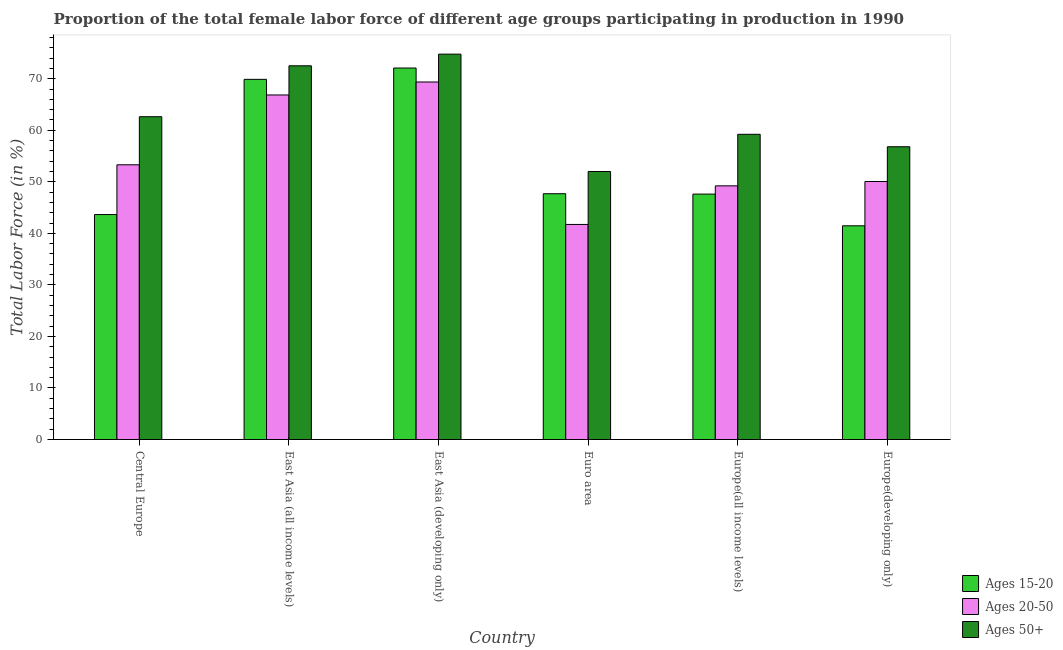How many different coloured bars are there?
Ensure brevity in your answer.  3. How many groups of bars are there?
Ensure brevity in your answer.  6. How many bars are there on the 2nd tick from the right?
Make the answer very short. 3. What is the label of the 5th group of bars from the left?
Provide a succinct answer. Europe(all income levels). In how many cases, is the number of bars for a given country not equal to the number of legend labels?
Your answer should be very brief. 0. What is the percentage of female labor force within the age group 15-20 in Euro area?
Provide a succinct answer. 47.69. Across all countries, what is the maximum percentage of female labor force within the age group 20-50?
Make the answer very short. 69.37. Across all countries, what is the minimum percentage of female labor force above age 50?
Offer a terse response. 52.01. In which country was the percentage of female labor force within the age group 20-50 maximum?
Keep it short and to the point. East Asia (developing only). What is the total percentage of female labor force within the age group 15-20 in the graph?
Your answer should be very brief. 322.39. What is the difference between the percentage of female labor force above age 50 in Central Europe and that in Europe(developing only)?
Offer a very short reply. 5.83. What is the difference between the percentage of female labor force within the age group 15-20 in East Asia (developing only) and the percentage of female labor force within the age group 20-50 in Europe(developing only)?
Your answer should be very brief. 22.02. What is the average percentage of female labor force within the age group 20-50 per country?
Your answer should be very brief. 55.09. What is the difference between the percentage of female labor force within the age group 15-20 and percentage of female labor force above age 50 in Europe(all income levels)?
Your answer should be compact. -11.6. What is the ratio of the percentage of female labor force above age 50 in Europe(all income levels) to that in Europe(developing only)?
Offer a very short reply. 1.04. What is the difference between the highest and the second highest percentage of female labor force above age 50?
Ensure brevity in your answer.  2.26. What is the difference between the highest and the lowest percentage of female labor force above age 50?
Provide a short and direct response. 22.77. Is the sum of the percentage of female labor force above age 50 in East Asia (developing only) and Euro area greater than the maximum percentage of female labor force within the age group 20-50 across all countries?
Offer a terse response. Yes. What does the 1st bar from the left in Euro area represents?
Provide a short and direct response. Ages 15-20. What does the 3rd bar from the right in Europe(developing only) represents?
Your answer should be compact. Ages 15-20. How many bars are there?
Ensure brevity in your answer.  18. Are all the bars in the graph horizontal?
Offer a terse response. No. How many countries are there in the graph?
Provide a succinct answer. 6. Are the values on the major ticks of Y-axis written in scientific E-notation?
Ensure brevity in your answer.  No. Does the graph contain grids?
Your answer should be compact. No. Where does the legend appear in the graph?
Your answer should be compact. Bottom right. How are the legend labels stacked?
Your answer should be compact. Vertical. What is the title of the graph?
Offer a terse response. Proportion of the total female labor force of different age groups participating in production in 1990. Does "Central government" appear as one of the legend labels in the graph?
Make the answer very short. No. What is the label or title of the X-axis?
Your answer should be very brief. Country. What is the label or title of the Y-axis?
Provide a succinct answer. Total Labor Force (in %). What is the Total Labor Force (in %) in Ages 15-20 in Central Europe?
Provide a succinct answer. 43.65. What is the Total Labor Force (in %) of Ages 20-50 in Central Europe?
Your response must be concise. 53.31. What is the Total Labor Force (in %) in Ages 50+ in Central Europe?
Ensure brevity in your answer.  62.64. What is the Total Labor Force (in %) in Ages 15-20 in East Asia (all income levels)?
Your response must be concise. 69.88. What is the Total Labor Force (in %) in Ages 20-50 in East Asia (all income levels)?
Keep it short and to the point. 66.85. What is the Total Labor Force (in %) of Ages 50+ in East Asia (all income levels)?
Offer a terse response. 72.51. What is the Total Labor Force (in %) in Ages 15-20 in East Asia (developing only)?
Give a very brief answer. 72.08. What is the Total Labor Force (in %) in Ages 20-50 in East Asia (developing only)?
Ensure brevity in your answer.  69.37. What is the Total Labor Force (in %) in Ages 50+ in East Asia (developing only)?
Make the answer very short. 74.77. What is the Total Labor Force (in %) in Ages 15-20 in Euro area?
Your response must be concise. 47.69. What is the Total Labor Force (in %) of Ages 20-50 in Euro area?
Provide a succinct answer. 41.73. What is the Total Labor Force (in %) in Ages 50+ in Euro area?
Give a very brief answer. 52.01. What is the Total Labor Force (in %) in Ages 15-20 in Europe(all income levels)?
Your answer should be compact. 47.62. What is the Total Labor Force (in %) in Ages 20-50 in Europe(all income levels)?
Give a very brief answer. 49.22. What is the Total Labor Force (in %) of Ages 50+ in Europe(all income levels)?
Your answer should be compact. 59.22. What is the Total Labor Force (in %) in Ages 15-20 in Europe(developing only)?
Offer a terse response. 41.47. What is the Total Labor Force (in %) in Ages 20-50 in Europe(developing only)?
Keep it short and to the point. 50.06. What is the Total Labor Force (in %) of Ages 50+ in Europe(developing only)?
Keep it short and to the point. 56.81. Across all countries, what is the maximum Total Labor Force (in %) in Ages 15-20?
Your answer should be compact. 72.08. Across all countries, what is the maximum Total Labor Force (in %) in Ages 20-50?
Your answer should be compact. 69.37. Across all countries, what is the maximum Total Labor Force (in %) of Ages 50+?
Keep it short and to the point. 74.77. Across all countries, what is the minimum Total Labor Force (in %) of Ages 15-20?
Your response must be concise. 41.47. Across all countries, what is the minimum Total Labor Force (in %) of Ages 20-50?
Offer a very short reply. 41.73. Across all countries, what is the minimum Total Labor Force (in %) in Ages 50+?
Provide a succinct answer. 52.01. What is the total Total Labor Force (in %) in Ages 15-20 in the graph?
Provide a short and direct response. 322.39. What is the total Total Labor Force (in %) in Ages 20-50 in the graph?
Ensure brevity in your answer.  330.54. What is the total Total Labor Force (in %) in Ages 50+ in the graph?
Give a very brief answer. 377.96. What is the difference between the Total Labor Force (in %) in Ages 15-20 in Central Europe and that in East Asia (all income levels)?
Give a very brief answer. -26.23. What is the difference between the Total Labor Force (in %) in Ages 20-50 in Central Europe and that in East Asia (all income levels)?
Ensure brevity in your answer.  -13.55. What is the difference between the Total Labor Force (in %) of Ages 50+ in Central Europe and that in East Asia (all income levels)?
Ensure brevity in your answer.  -9.88. What is the difference between the Total Labor Force (in %) in Ages 15-20 in Central Europe and that in East Asia (developing only)?
Your answer should be compact. -28.43. What is the difference between the Total Labor Force (in %) in Ages 20-50 in Central Europe and that in East Asia (developing only)?
Provide a succinct answer. -16.07. What is the difference between the Total Labor Force (in %) of Ages 50+ in Central Europe and that in East Asia (developing only)?
Give a very brief answer. -12.14. What is the difference between the Total Labor Force (in %) in Ages 15-20 in Central Europe and that in Euro area?
Make the answer very short. -4.04. What is the difference between the Total Labor Force (in %) of Ages 20-50 in Central Europe and that in Euro area?
Offer a terse response. 11.58. What is the difference between the Total Labor Force (in %) of Ages 50+ in Central Europe and that in Euro area?
Your answer should be compact. 10.63. What is the difference between the Total Labor Force (in %) of Ages 15-20 in Central Europe and that in Europe(all income levels)?
Offer a very short reply. -3.97. What is the difference between the Total Labor Force (in %) of Ages 20-50 in Central Europe and that in Europe(all income levels)?
Your answer should be compact. 4.08. What is the difference between the Total Labor Force (in %) of Ages 50+ in Central Europe and that in Europe(all income levels)?
Your response must be concise. 3.41. What is the difference between the Total Labor Force (in %) of Ages 15-20 in Central Europe and that in Europe(developing only)?
Give a very brief answer. 2.18. What is the difference between the Total Labor Force (in %) of Ages 20-50 in Central Europe and that in Europe(developing only)?
Your answer should be very brief. 3.24. What is the difference between the Total Labor Force (in %) in Ages 50+ in Central Europe and that in Europe(developing only)?
Your response must be concise. 5.83. What is the difference between the Total Labor Force (in %) in Ages 15-20 in East Asia (all income levels) and that in East Asia (developing only)?
Provide a short and direct response. -2.2. What is the difference between the Total Labor Force (in %) of Ages 20-50 in East Asia (all income levels) and that in East Asia (developing only)?
Make the answer very short. -2.52. What is the difference between the Total Labor Force (in %) in Ages 50+ in East Asia (all income levels) and that in East Asia (developing only)?
Offer a very short reply. -2.26. What is the difference between the Total Labor Force (in %) of Ages 15-20 in East Asia (all income levels) and that in Euro area?
Make the answer very short. 22.19. What is the difference between the Total Labor Force (in %) of Ages 20-50 in East Asia (all income levels) and that in Euro area?
Provide a succinct answer. 25.12. What is the difference between the Total Labor Force (in %) in Ages 50+ in East Asia (all income levels) and that in Euro area?
Offer a very short reply. 20.51. What is the difference between the Total Labor Force (in %) of Ages 15-20 in East Asia (all income levels) and that in Europe(all income levels)?
Provide a succinct answer. 22.26. What is the difference between the Total Labor Force (in %) of Ages 20-50 in East Asia (all income levels) and that in Europe(all income levels)?
Ensure brevity in your answer.  17.63. What is the difference between the Total Labor Force (in %) in Ages 50+ in East Asia (all income levels) and that in Europe(all income levels)?
Make the answer very short. 13.29. What is the difference between the Total Labor Force (in %) in Ages 15-20 in East Asia (all income levels) and that in Europe(developing only)?
Make the answer very short. 28.41. What is the difference between the Total Labor Force (in %) in Ages 20-50 in East Asia (all income levels) and that in Europe(developing only)?
Keep it short and to the point. 16.79. What is the difference between the Total Labor Force (in %) in Ages 50+ in East Asia (all income levels) and that in Europe(developing only)?
Keep it short and to the point. 15.7. What is the difference between the Total Labor Force (in %) in Ages 15-20 in East Asia (developing only) and that in Euro area?
Ensure brevity in your answer.  24.39. What is the difference between the Total Labor Force (in %) of Ages 20-50 in East Asia (developing only) and that in Euro area?
Your answer should be compact. 27.64. What is the difference between the Total Labor Force (in %) in Ages 50+ in East Asia (developing only) and that in Euro area?
Keep it short and to the point. 22.77. What is the difference between the Total Labor Force (in %) of Ages 15-20 in East Asia (developing only) and that in Europe(all income levels)?
Provide a short and direct response. 24.46. What is the difference between the Total Labor Force (in %) of Ages 20-50 in East Asia (developing only) and that in Europe(all income levels)?
Offer a very short reply. 20.15. What is the difference between the Total Labor Force (in %) of Ages 50+ in East Asia (developing only) and that in Europe(all income levels)?
Your answer should be compact. 15.55. What is the difference between the Total Labor Force (in %) of Ages 15-20 in East Asia (developing only) and that in Europe(developing only)?
Your answer should be very brief. 30.61. What is the difference between the Total Labor Force (in %) in Ages 20-50 in East Asia (developing only) and that in Europe(developing only)?
Your response must be concise. 19.31. What is the difference between the Total Labor Force (in %) in Ages 50+ in East Asia (developing only) and that in Europe(developing only)?
Give a very brief answer. 17.97. What is the difference between the Total Labor Force (in %) of Ages 15-20 in Euro area and that in Europe(all income levels)?
Your response must be concise. 0.07. What is the difference between the Total Labor Force (in %) in Ages 20-50 in Euro area and that in Europe(all income levels)?
Your answer should be very brief. -7.49. What is the difference between the Total Labor Force (in %) of Ages 50+ in Euro area and that in Europe(all income levels)?
Offer a very short reply. -7.22. What is the difference between the Total Labor Force (in %) in Ages 15-20 in Euro area and that in Europe(developing only)?
Make the answer very short. 6.22. What is the difference between the Total Labor Force (in %) of Ages 20-50 in Euro area and that in Europe(developing only)?
Your answer should be compact. -8.33. What is the difference between the Total Labor Force (in %) in Ages 50+ in Euro area and that in Europe(developing only)?
Your response must be concise. -4.8. What is the difference between the Total Labor Force (in %) in Ages 15-20 in Europe(all income levels) and that in Europe(developing only)?
Make the answer very short. 6.15. What is the difference between the Total Labor Force (in %) of Ages 20-50 in Europe(all income levels) and that in Europe(developing only)?
Provide a succinct answer. -0.84. What is the difference between the Total Labor Force (in %) in Ages 50+ in Europe(all income levels) and that in Europe(developing only)?
Your answer should be very brief. 2.41. What is the difference between the Total Labor Force (in %) in Ages 15-20 in Central Europe and the Total Labor Force (in %) in Ages 20-50 in East Asia (all income levels)?
Provide a short and direct response. -23.2. What is the difference between the Total Labor Force (in %) in Ages 15-20 in Central Europe and the Total Labor Force (in %) in Ages 50+ in East Asia (all income levels)?
Give a very brief answer. -28.86. What is the difference between the Total Labor Force (in %) of Ages 20-50 in Central Europe and the Total Labor Force (in %) of Ages 50+ in East Asia (all income levels)?
Give a very brief answer. -19.21. What is the difference between the Total Labor Force (in %) in Ages 15-20 in Central Europe and the Total Labor Force (in %) in Ages 20-50 in East Asia (developing only)?
Your answer should be compact. -25.72. What is the difference between the Total Labor Force (in %) of Ages 15-20 in Central Europe and the Total Labor Force (in %) of Ages 50+ in East Asia (developing only)?
Make the answer very short. -31.12. What is the difference between the Total Labor Force (in %) of Ages 20-50 in Central Europe and the Total Labor Force (in %) of Ages 50+ in East Asia (developing only)?
Ensure brevity in your answer.  -21.47. What is the difference between the Total Labor Force (in %) in Ages 15-20 in Central Europe and the Total Labor Force (in %) in Ages 20-50 in Euro area?
Make the answer very short. 1.92. What is the difference between the Total Labor Force (in %) in Ages 15-20 in Central Europe and the Total Labor Force (in %) in Ages 50+ in Euro area?
Ensure brevity in your answer.  -8.36. What is the difference between the Total Labor Force (in %) of Ages 20-50 in Central Europe and the Total Labor Force (in %) of Ages 50+ in Euro area?
Provide a short and direct response. 1.3. What is the difference between the Total Labor Force (in %) in Ages 15-20 in Central Europe and the Total Labor Force (in %) in Ages 20-50 in Europe(all income levels)?
Make the answer very short. -5.57. What is the difference between the Total Labor Force (in %) in Ages 15-20 in Central Europe and the Total Labor Force (in %) in Ages 50+ in Europe(all income levels)?
Keep it short and to the point. -15.57. What is the difference between the Total Labor Force (in %) in Ages 20-50 in Central Europe and the Total Labor Force (in %) in Ages 50+ in Europe(all income levels)?
Provide a succinct answer. -5.92. What is the difference between the Total Labor Force (in %) of Ages 15-20 in Central Europe and the Total Labor Force (in %) of Ages 20-50 in Europe(developing only)?
Provide a succinct answer. -6.41. What is the difference between the Total Labor Force (in %) of Ages 15-20 in Central Europe and the Total Labor Force (in %) of Ages 50+ in Europe(developing only)?
Offer a terse response. -13.16. What is the difference between the Total Labor Force (in %) in Ages 20-50 in Central Europe and the Total Labor Force (in %) in Ages 50+ in Europe(developing only)?
Your response must be concise. -3.5. What is the difference between the Total Labor Force (in %) of Ages 15-20 in East Asia (all income levels) and the Total Labor Force (in %) of Ages 20-50 in East Asia (developing only)?
Provide a short and direct response. 0.51. What is the difference between the Total Labor Force (in %) of Ages 15-20 in East Asia (all income levels) and the Total Labor Force (in %) of Ages 50+ in East Asia (developing only)?
Offer a terse response. -4.89. What is the difference between the Total Labor Force (in %) of Ages 20-50 in East Asia (all income levels) and the Total Labor Force (in %) of Ages 50+ in East Asia (developing only)?
Your answer should be very brief. -7.92. What is the difference between the Total Labor Force (in %) in Ages 15-20 in East Asia (all income levels) and the Total Labor Force (in %) in Ages 20-50 in Euro area?
Give a very brief answer. 28.15. What is the difference between the Total Labor Force (in %) of Ages 15-20 in East Asia (all income levels) and the Total Labor Force (in %) of Ages 50+ in Euro area?
Give a very brief answer. 17.88. What is the difference between the Total Labor Force (in %) of Ages 20-50 in East Asia (all income levels) and the Total Labor Force (in %) of Ages 50+ in Euro area?
Make the answer very short. 14.85. What is the difference between the Total Labor Force (in %) of Ages 15-20 in East Asia (all income levels) and the Total Labor Force (in %) of Ages 20-50 in Europe(all income levels)?
Make the answer very short. 20.66. What is the difference between the Total Labor Force (in %) in Ages 15-20 in East Asia (all income levels) and the Total Labor Force (in %) in Ages 50+ in Europe(all income levels)?
Your response must be concise. 10.66. What is the difference between the Total Labor Force (in %) in Ages 20-50 in East Asia (all income levels) and the Total Labor Force (in %) in Ages 50+ in Europe(all income levels)?
Make the answer very short. 7.63. What is the difference between the Total Labor Force (in %) in Ages 15-20 in East Asia (all income levels) and the Total Labor Force (in %) in Ages 20-50 in Europe(developing only)?
Your answer should be very brief. 19.82. What is the difference between the Total Labor Force (in %) in Ages 15-20 in East Asia (all income levels) and the Total Labor Force (in %) in Ages 50+ in Europe(developing only)?
Provide a succinct answer. 13.07. What is the difference between the Total Labor Force (in %) of Ages 20-50 in East Asia (all income levels) and the Total Labor Force (in %) of Ages 50+ in Europe(developing only)?
Your answer should be very brief. 10.04. What is the difference between the Total Labor Force (in %) in Ages 15-20 in East Asia (developing only) and the Total Labor Force (in %) in Ages 20-50 in Euro area?
Your answer should be very brief. 30.35. What is the difference between the Total Labor Force (in %) of Ages 15-20 in East Asia (developing only) and the Total Labor Force (in %) of Ages 50+ in Euro area?
Your answer should be very brief. 20.08. What is the difference between the Total Labor Force (in %) of Ages 20-50 in East Asia (developing only) and the Total Labor Force (in %) of Ages 50+ in Euro area?
Keep it short and to the point. 17.37. What is the difference between the Total Labor Force (in %) in Ages 15-20 in East Asia (developing only) and the Total Labor Force (in %) in Ages 20-50 in Europe(all income levels)?
Your answer should be compact. 22.86. What is the difference between the Total Labor Force (in %) of Ages 15-20 in East Asia (developing only) and the Total Labor Force (in %) of Ages 50+ in Europe(all income levels)?
Give a very brief answer. 12.86. What is the difference between the Total Labor Force (in %) of Ages 20-50 in East Asia (developing only) and the Total Labor Force (in %) of Ages 50+ in Europe(all income levels)?
Ensure brevity in your answer.  10.15. What is the difference between the Total Labor Force (in %) in Ages 15-20 in East Asia (developing only) and the Total Labor Force (in %) in Ages 20-50 in Europe(developing only)?
Keep it short and to the point. 22.02. What is the difference between the Total Labor Force (in %) in Ages 15-20 in East Asia (developing only) and the Total Labor Force (in %) in Ages 50+ in Europe(developing only)?
Your answer should be compact. 15.27. What is the difference between the Total Labor Force (in %) of Ages 20-50 in East Asia (developing only) and the Total Labor Force (in %) of Ages 50+ in Europe(developing only)?
Offer a very short reply. 12.56. What is the difference between the Total Labor Force (in %) of Ages 15-20 in Euro area and the Total Labor Force (in %) of Ages 20-50 in Europe(all income levels)?
Your answer should be very brief. -1.53. What is the difference between the Total Labor Force (in %) in Ages 15-20 in Euro area and the Total Labor Force (in %) in Ages 50+ in Europe(all income levels)?
Provide a succinct answer. -11.53. What is the difference between the Total Labor Force (in %) in Ages 20-50 in Euro area and the Total Labor Force (in %) in Ages 50+ in Europe(all income levels)?
Offer a very short reply. -17.49. What is the difference between the Total Labor Force (in %) of Ages 15-20 in Euro area and the Total Labor Force (in %) of Ages 20-50 in Europe(developing only)?
Your answer should be compact. -2.37. What is the difference between the Total Labor Force (in %) in Ages 15-20 in Euro area and the Total Labor Force (in %) in Ages 50+ in Europe(developing only)?
Ensure brevity in your answer.  -9.12. What is the difference between the Total Labor Force (in %) in Ages 20-50 in Euro area and the Total Labor Force (in %) in Ages 50+ in Europe(developing only)?
Offer a terse response. -15.08. What is the difference between the Total Labor Force (in %) of Ages 15-20 in Europe(all income levels) and the Total Labor Force (in %) of Ages 20-50 in Europe(developing only)?
Your answer should be compact. -2.44. What is the difference between the Total Labor Force (in %) of Ages 15-20 in Europe(all income levels) and the Total Labor Force (in %) of Ages 50+ in Europe(developing only)?
Provide a short and direct response. -9.19. What is the difference between the Total Labor Force (in %) of Ages 20-50 in Europe(all income levels) and the Total Labor Force (in %) of Ages 50+ in Europe(developing only)?
Your answer should be very brief. -7.59. What is the average Total Labor Force (in %) of Ages 15-20 per country?
Ensure brevity in your answer.  53.73. What is the average Total Labor Force (in %) in Ages 20-50 per country?
Provide a short and direct response. 55.09. What is the average Total Labor Force (in %) of Ages 50+ per country?
Ensure brevity in your answer.  62.99. What is the difference between the Total Labor Force (in %) in Ages 15-20 and Total Labor Force (in %) in Ages 20-50 in Central Europe?
Ensure brevity in your answer.  -9.65. What is the difference between the Total Labor Force (in %) of Ages 15-20 and Total Labor Force (in %) of Ages 50+ in Central Europe?
Provide a short and direct response. -18.98. What is the difference between the Total Labor Force (in %) of Ages 20-50 and Total Labor Force (in %) of Ages 50+ in Central Europe?
Offer a very short reply. -9.33. What is the difference between the Total Labor Force (in %) of Ages 15-20 and Total Labor Force (in %) of Ages 20-50 in East Asia (all income levels)?
Ensure brevity in your answer.  3.03. What is the difference between the Total Labor Force (in %) of Ages 15-20 and Total Labor Force (in %) of Ages 50+ in East Asia (all income levels)?
Make the answer very short. -2.63. What is the difference between the Total Labor Force (in %) in Ages 20-50 and Total Labor Force (in %) in Ages 50+ in East Asia (all income levels)?
Provide a succinct answer. -5.66. What is the difference between the Total Labor Force (in %) in Ages 15-20 and Total Labor Force (in %) in Ages 20-50 in East Asia (developing only)?
Your answer should be very brief. 2.71. What is the difference between the Total Labor Force (in %) of Ages 15-20 and Total Labor Force (in %) of Ages 50+ in East Asia (developing only)?
Your response must be concise. -2.69. What is the difference between the Total Labor Force (in %) in Ages 20-50 and Total Labor Force (in %) in Ages 50+ in East Asia (developing only)?
Ensure brevity in your answer.  -5.4. What is the difference between the Total Labor Force (in %) of Ages 15-20 and Total Labor Force (in %) of Ages 20-50 in Euro area?
Give a very brief answer. 5.96. What is the difference between the Total Labor Force (in %) in Ages 15-20 and Total Labor Force (in %) in Ages 50+ in Euro area?
Keep it short and to the point. -4.32. What is the difference between the Total Labor Force (in %) of Ages 20-50 and Total Labor Force (in %) of Ages 50+ in Euro area?
Offer a terse response. -10.28. What is the difference between the Total Labor Force (in %) in Ages 15-20 and Total Labor Force (in %) in Ages 20-50 in Europe(all income levels)?
Your answer should be compact. -1.6. What is the difference between the Total Labor Force (in %) of Ages 15-20 and Total Labor Force (in %) of Ages 50+ in Europe(all income levels)?
Your response must be concise. -11.6. What is the difference between the Total Labor Force (in %) in Ages 20-50 and Total Labor Force (in %) in Ages 50+ in Europe(all income levels)?
Your response must be concise. -10. What is the difference between the Total Labor Force (in %) of Ages 15-20 and Total Labor Force (in %) of Ages 20-50 in Europe(developing only)?
Ensure brevity in your answer.  -8.59. What is the difference between the Total Labor Force (in %) in Ages 15-20 and Total Labor Force (in %) in Ages 50+ in Europe(developing only)?
Offer a terse response. -15.34. What is the difference between the Total Labor Force (in %) in Ages 20-50 and Total Labor Force (in %) in Ages 50+ in Europe(developing only)?
Your response must be concise. -6.75. What is the ratio of the Total Labor Force (in %) of Ages 15-20 in Central Europe to that in East Asia (all income levels)?
Give a very brief answer. 0.62. What is the ratio of the Total Labor Force (in %) of Ages 20-50 in Central Europe to that in East Asia (all income levels)?
Ensure brevity in your answer.  0.8. What is the ratio of the Total Labor Force (in %) of Ages 50+ in Central Europe to that in East Asia (all income levels)?
Ensure brevity in your answer.  0.86. What is the ratio of the Total Labor Force (in %) in Ages 15-20 in Central Europe to that in East Asia (developing only)?
Provide a succinct answer. 0.61. What is the ratio of the Total Labor Force (in %) of Ages 20-50 in Central Europe to that in East Asia (developing only)?
Give a very brief answer. 0.77. What is the ratio of the Total Labor Force (in %) in Ages 50+ in Central Europe to that in East Asia (developing only)?
Give a very brief answer. 0.84. What is the ratio of the Total Labor Force (in %) of Ages 15-20 in Central Europe to that in Euro area?
Ensure brevity in your answer.  0.92. What is the ratio of the Total Labor Force (in %) in Ages 20-50 in Central Europe to that in Euro area?
Your answer should be very brief. 1.28. What is the ratio of the Total Labor Force (in %) of Ages 50+ in Central Europe to that in Euro area?
Ensure brevity in your answer.  1.2. What is the ratio of the Total Labor Force (in %) of Ages 20-50 in Central Europe to that in Europe(all income levels)?
Provide a short and direct response. 1.08. What is the ratio of the Total Labor Force (in %) of Ages 50+ in Central Europe to that in Europe(all income levels)?
Offer a terse response. 1.06. What is the ratio of the Total Labor Force (in %) of Ages 15-20 in Central Europe to that in Europe(developing only)?
Make the answer very short. 1.05. What is the ratio of the Total Labor Force (in %) of Ages 20-50 in Central Europe to that in Europe(developing only)?
Your response must be concise. 1.06. What is the ratio of the Total Labor Force (in %) of Ages 50+ in Central Europe to that in Europe(developing only)?
Your answer should be very brief. 1.1. What is the ratio of the Total Labor Force (in %) of Ages 15-20 in East Asia (all income levels) to that in East Asia (developing only)?
Provide a succinct answer. 0.97. What is the ratio of the Total Labor Force (in %) in Ages 20-50 in East Asia (all income levels) to that in East Asia (developing only)?
Your response must be concise. 0.96. What is the ratio of the Total Labor Force (in %) in Ages 50+ in East Asia (all income levels) to that in East Asia (developing only)?
Ensure brevity in your answer.  0.97. What is the ratio of the Total Labor Force (in %) of Ages 15-20 in East Asia (all income levels) to that in Euro area?
Your answer should be very brief. 1.47. What is the ratio of the Total Labor Force (in %) of Ages 20-50 in East Asia (all income levels) to that in Euro area?
Keep it short and to the point. 1.6. What is the ratio of the Total Labor Force (in %) in Ages 50+ in East Asia (all income levels) to that in Euro area?
Offer a very short reply. 1.39. What is the ratio of the Total Labor Force (in %) in Ages 15-20 in East Asia (all income levels) to that in Europe(all income levels)?
Provide a succinct answer. 1.47. What is the ratio of the Total Labor Force (in %) in Ages 20-50 in East Asia (all income levels) to that in Europe(all income levels)?
Give a very brief answer. 1.36. What is the ratio of the Total Labor Force (in %) in Ages 50+ in East Asia (all income levels) to that in Europe(all income levels)?
Keep it short and to the point. 1.22. What is the ratio of the Total Labor Force (in %) of Ages 15-20 in East Asia (all income levels) to that in Europe(developing only)?
Offer a very short reply. 1.69. What is the ratio of the Total Labor Force (in %) in Ages 20-50 in East Asia (all income levels) to that in Europe(developing only)?
Your answer should be compact. 1.34. What is the ratio of the Total Labor Force (in %) of Ages 50+ in East Asia (all income levels) to that in Europe(developing only)?
Give a very brief answer. 1.28. What is the ratio of the Total Labor Force (in %) in Ages 15-20 in East Asia (developing only) to that in Euro area?
Your answer should be very brief. 1.51. What is the ratio of the Total Labor Force (in %) in Ages 20-50 in East Asia (developing only) to that in Euro area?
Offer a terse response. 1.66. What is the ratio of the Total Labor Force (in %) in Ages 50+ in East Asia (developing only) to that in Euro area?
Your response must be concise. 1.44. What is the ratio of the Total Labor Force (in %) in Ages 15-20 in East Asia (developing only) to that in Europe(all income levels)?
Give a very brief answer. 1.51. What is the ratio of the Total Labor Force (in %) in Ages 20-50 in East Asia (developing only) to that in Europe(all income levels)?
Provide a short and direct response. 1.41. What is the ratio of the Total Labor Force (in %) of Ages 50+ in East Asia (developing only) to that in Europe(all income levels)?
Provide a short and direct response. 1.26. What is the ratio of the Total Labor Force (in %) in Ages 15-20 in East Asia (developing only) to that in Europe(developing only)?
Your response must be concise. 1.74. What is the ratio of the Total Labor Force (in %) in Ages 20-50 in East Asia (developing only) to that in Europe(developing only)?
Your answer should be compact. 1.39. What is the ratio of the Total Labor Force (in %) in Ages 50+ in East Asia (developing only) to that in Europe(developing only)?
Keep it short and to the point. 1.32. What is the ratio of the Total Labor Force (in %) in Ages 15-20 in Euro area to that in Europe(all income levels)?
Offer a very short reply. 1. What is the ratio of the Total Labor Force (in %) in Ages 20-50 in Euro area to that in Europe(all income levels)?
Provide a succinct answer. 0.85. What is the ratio of the Total Labor Force (in %) in Ages 50+ in Euro area to that in Europe(all income levels)?
Offer a terse response. 0.88. What is the ratio of the Total Labor Force (in %) of Ages 15-20 in Euro area to that in Europe(developing only)?
Your answer should be compact. 1.15. What is the ratio of the Total Labor Force (in %) of Ages 20-50 in Euro area to that in Europe(developing only)?
Give a very brief answer. 0.83. What is the ratio of the Total Labor Force (in %) in Ages 50+ in Euro area to that in Europe(developing only)?
Ensure brevity in your answer.  0.92. What is the ratio of the Total Labor Force (in %) in Ages 15-20 in Europe(all income levels) to that in Europe(developing only)?
Ensure brevity in your answer.  1.15. What is the ratio of the Total Labor Force (in %) in Ages 20-50 in Europe(all income levels) to that in Europe(developing only)?
Provide a succinct answer. 0.98. What is the ratio of the Total Labor Force (in %) in Ages 50+ in Europe(all income levels) to that in Europe(developing only)?
Make the answer very short. 1.04. What is the difference between the highest and the second highest Total Labor Force (in %) of Ages 20-50?
Offer a terse response. 2.52. What is the difference between the highest and the second highest Total Labor Force (in %) of Ages 50+?
Your response must be concise. 2.26. What is the difference between the highest and the lowest Total Labor Force (in %) in Ages 15-20?
Keep it short and to the point. 30.61. What is the difference between the highest and the lowest Total Labor Force (in %) in Ages 20-50?
Offer a terse response. 27.64. What is the difference between the highest and the lowest Total Labor Force (in %) of Ages 50+?
Your response must be concise. 22.77. 